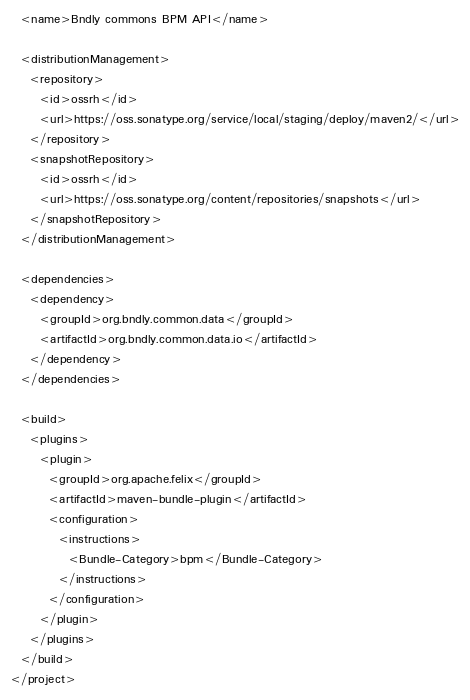Convert code to text. <code><loc_0><loc_0><loc_500><loc_500><_XML_>  <name>Bndly commons BPM API</name>

  <distributionManagement>
    <repository>
      <id>ossrh</id>
      <url>https://oss.sonatype.org/service/local/staging/deploy/maven2/</url>
    </repository>
    <snapshotRepository>
      <id>ossrh</id>
      <url>https://oss.sonatype.org/content/repositories/snapshots</url>
    </snapshotRepository>
  </distributionManagement>

  <dependencies>
    <dependency>
      <groupId>org.bndly.common.data</groupId>
      <artifactId>org.bndly.common.data.io</artifactId>
    </dependency>
  </dependencies>

  <build>
    <plugins>
      <plugin>
        <groupId>org.apache.felix</groupId>
        <artifactId>maven-bundle-plugin</artifactId>
        <configuration>
          <instructions>
            <Bundle-Category>bpm</Bundle-Category>
          </instructions>
        </configuration>
      </plugin>
    </plugins>
  </build>
</project>
</code> 